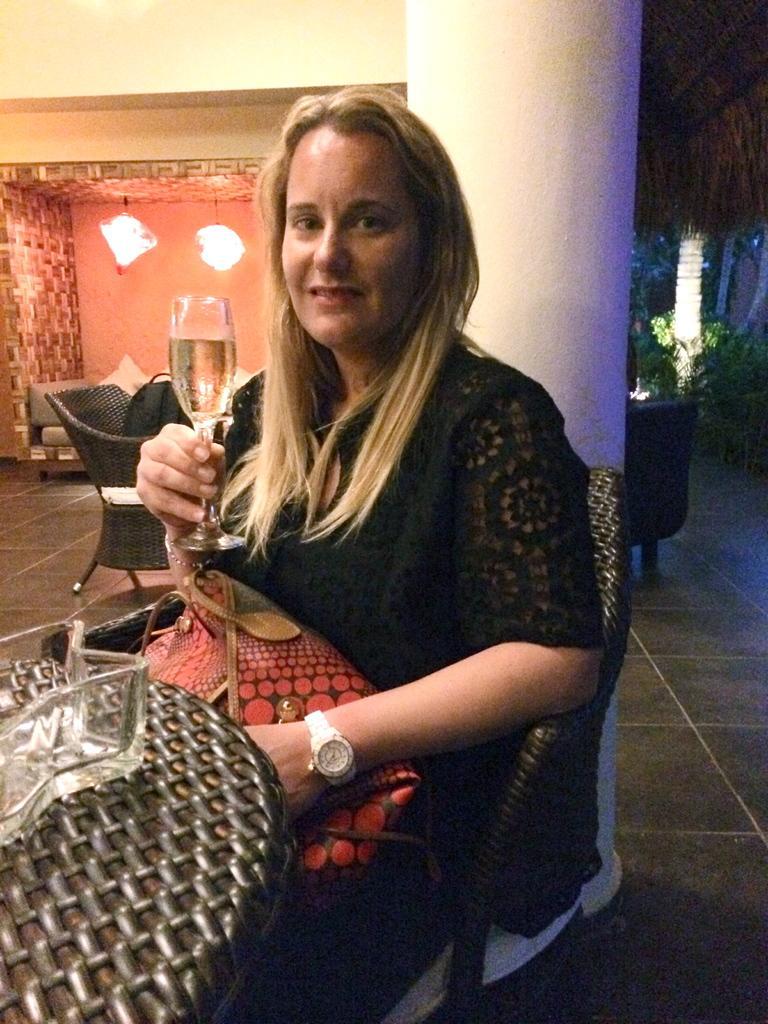In one or two sentences, can you explain what this image depicts? In the image we can see there is a woman who is sitting on the chair and she is holding a wine glass. On her lap there is red colour bag in front of her there is a table on which there is a glass bowl. She is wearing a white colour wrist watch behind her there is a white colour pillar. Beside of the pillar there are lights which are hanging from the top. 